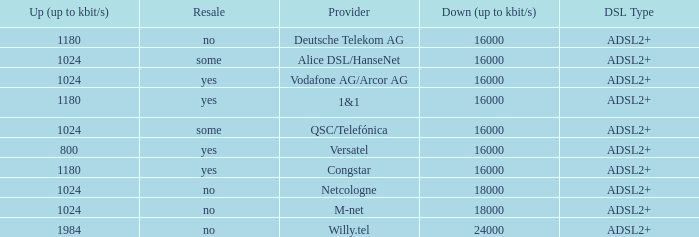Who are all of the telecom providers for which the upload rate is 1024 kbits and the resale category is yes? Vodafone AG/Arcor AG. 